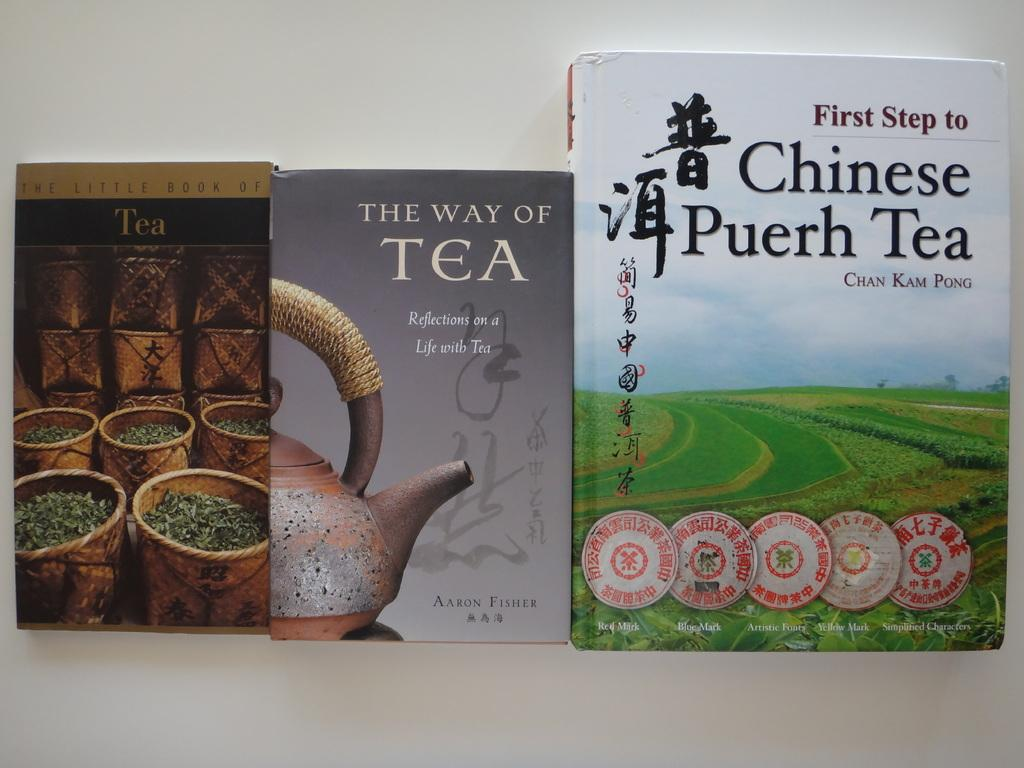<image>
Render a clear and concise summary of the photo. Three different books with titles related to Tea stand next to each other with their covers visible. 